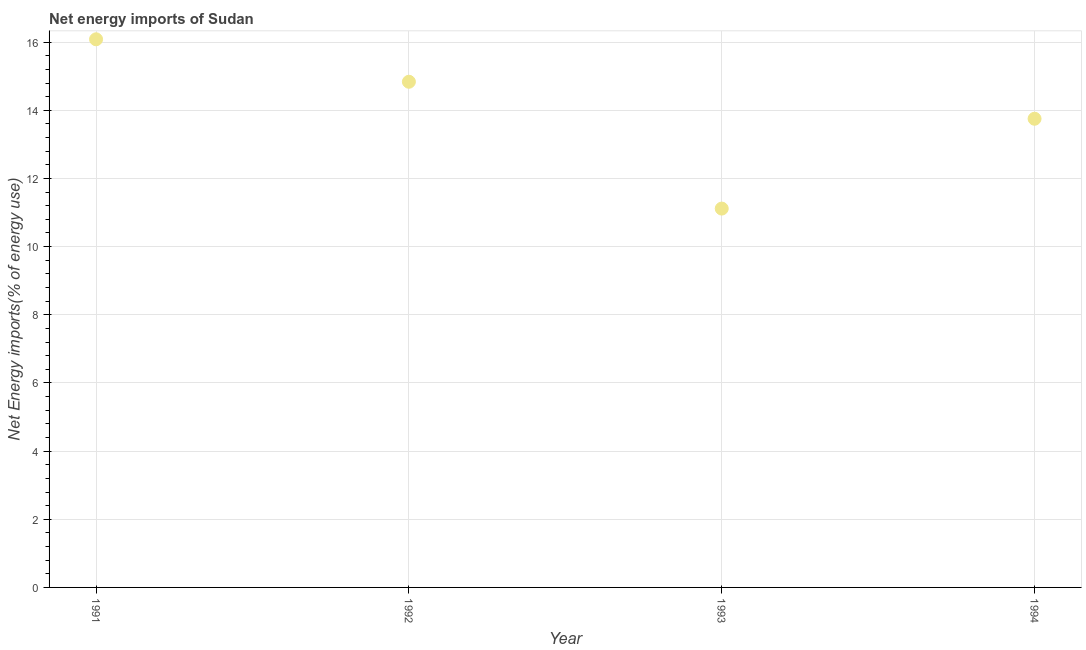What is the energy imports in 1993?
Your answer should be compact. 11.12. Across all years, what is the maximum energy imports?
Give a very brief answer. 16.08. Across all years, what is the minimum energy imports?
Give a very brief answer. 11.12. What is the sum of the energy imports?
Ensure brevity in your answer.  55.79. What is the difference between the energy imports in 1991 and 1992?
Provide a succinct answer. 1.25. What is the average energy imports per year?
Your response must be concise. 13.95. What is the median energy imports?
Give a very brief answer. 14.3. In how many years, is the energy imports greater than 6.8 %?
Your answer should be compact. 4. Do a majority of the years between 1992 and 1993 (inclusive) have energy imports greater than 5.2 %?
Ensure brevity in your answer.  Yes. What is the ratio of the energy imports in 1991 to that in 1993?
Your answer should be very brief. 1.45. Is the energy imports in 1991 less than that in 1992?
Offer a very short reply. No. Is the difference between the energy imports in 1991 and 1992 greater than the difference between any two years?
Give a very brief answer. No. What is the difference between the highest and the second highest energy imports?
Ensure brevity in your answer.  1.25. Is the sum of the energy imports in 1991 and 1993 greater than the maximum energy imports across all years?
Your response must be concise. Yes. What is the difference between the highest and the lowest energy imports?
Ensure brevity in your answer.  4.97. In how many years, is the energy imports greater than the average energy imports taken over all years?
Make the answer very short. 2. Does the energy imports monotonically increase over the years?
Give a very brief answer. No. How many dotlines are there?
Keep it short and to the point. 1. How many years are there in the graph?
Provide a succinct answer. 4. Are the values on the major ticks of Y-axis written in scientific E-notation?
Give a very brief answer. No. What is the title of the graph?
Your response must be concise. Net energy imports of Sudan. What is the label or title of the X-axis?
Provide a succinct answer. Year. What is the label or title of the Y-axis?
Make the answer very short. Net Energy imports(% of energy use). What is the Net Energy imports(% of energy use) in 1991?
Give a very brief answer. 16.08. What is the Net Energy imports(% of energy use) in 1992?
Provide a short and direct response. 14.84. What is the Net Energy imports(% of energy use) in 1993?
Keep it short and to the point. 11.12. What is the Net Energy imports(% of energy use) in 1994?
Your answer should be very brief. 13.75. What is the difference between the Net Energy imports(% of energy use) in 1991 and 1992?
Give a very brief answer. 1.25. What is the difference between the Net Energy imports(% of energy use) in 1991 and 1993?
Make the answer very short. 4.97. What is the difference between the Net Energy imports(% of energy use) in 1991 and 1994?
Keep it short and to the point. 2.33. What is the difference between the Net Energy imports(% of energy use) in 1992 and 1993?
Give a very brief answer. 3.72. What is the difference between the Net Energy imports(% of energy use) in 1992 and 1994?
Ensure brevity in your answer.  1.09. What is the difference between the Net Energy imports(% of energy use) in 1993 and 1994?
Keep it short and to the point. -2.64. What is the ratio of the Net Energy imports(% of energy use) in 1991 to that in 1992?
Provide a short and direct response. 1.08. What is the ratio of the Net Energy imports(% of energy use) in 1991 to that in 1993?
Offer a terse response. 1.45. What is the ratio of the Net Energy imports(% of energy use) in 1991 to that in 1994?
Give a very brief answer. 1.17. What is the ratio of the Net Energy imports(% of energy use) in 1992 to that in 1993?
Give a very brief answer. 1.33. What is the ratio of the Net Energy imports(% of energy use) in 1992 to that in 1994?
Give a very brief answer. 1.08. What is the ratio of the Net Energy imports(% of energy use) in 1993 to that in 1994?
Your answer should be compact. 0.81. 